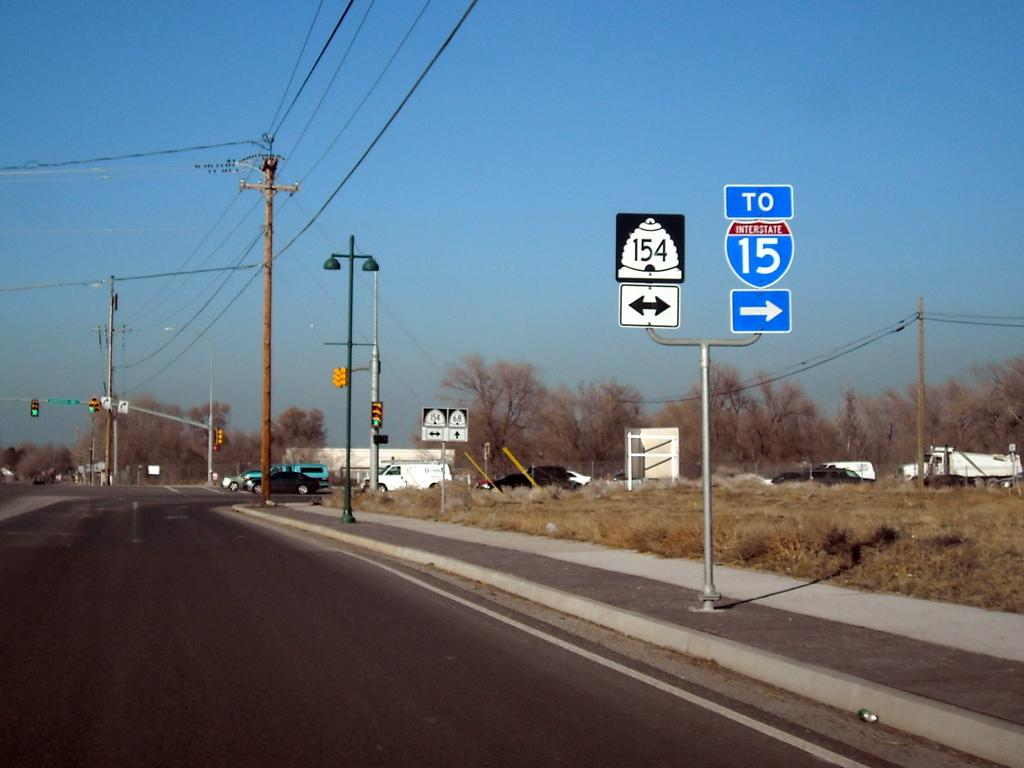<image>
Write a terse but informative summary of the picture. the number 15 is on a blue sign outside 